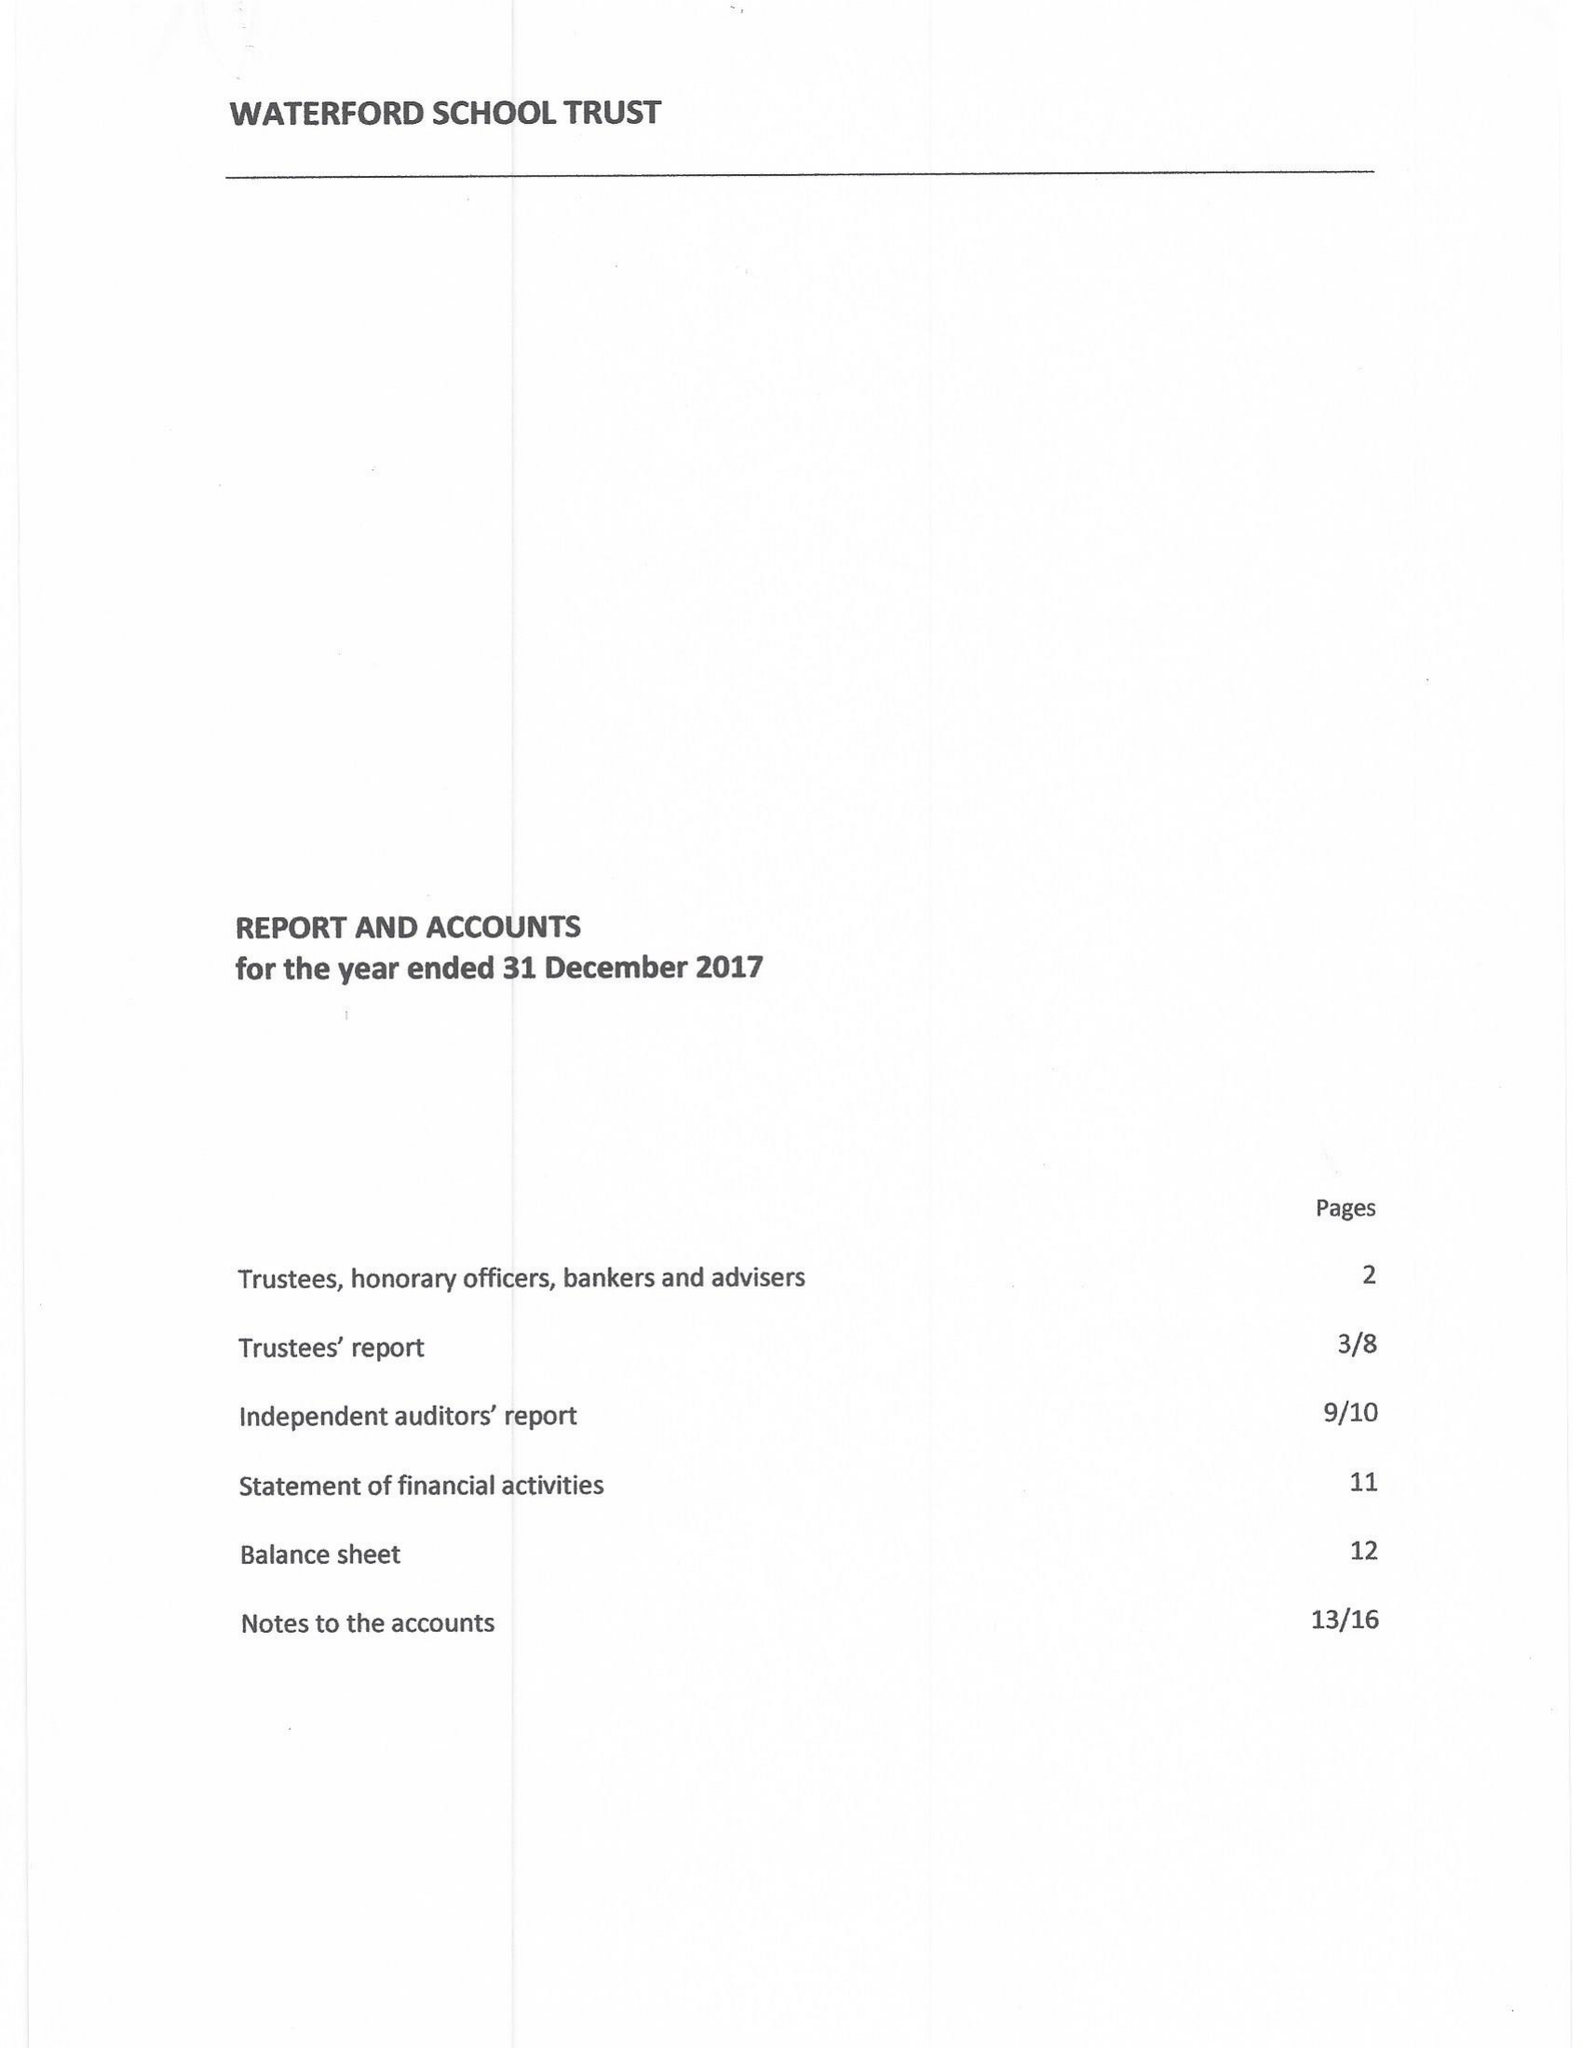What is the value for the income_annually_in_british_pounds?
Answer the question using a single word or phrase. 62530.00 